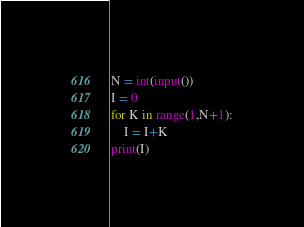<code> <loc_0><loc_0><loc_500><loc_500><_Python_>N = int(input())
I = 0
for K in range(1,N+1):
    I = I+K
print(I)</code> 